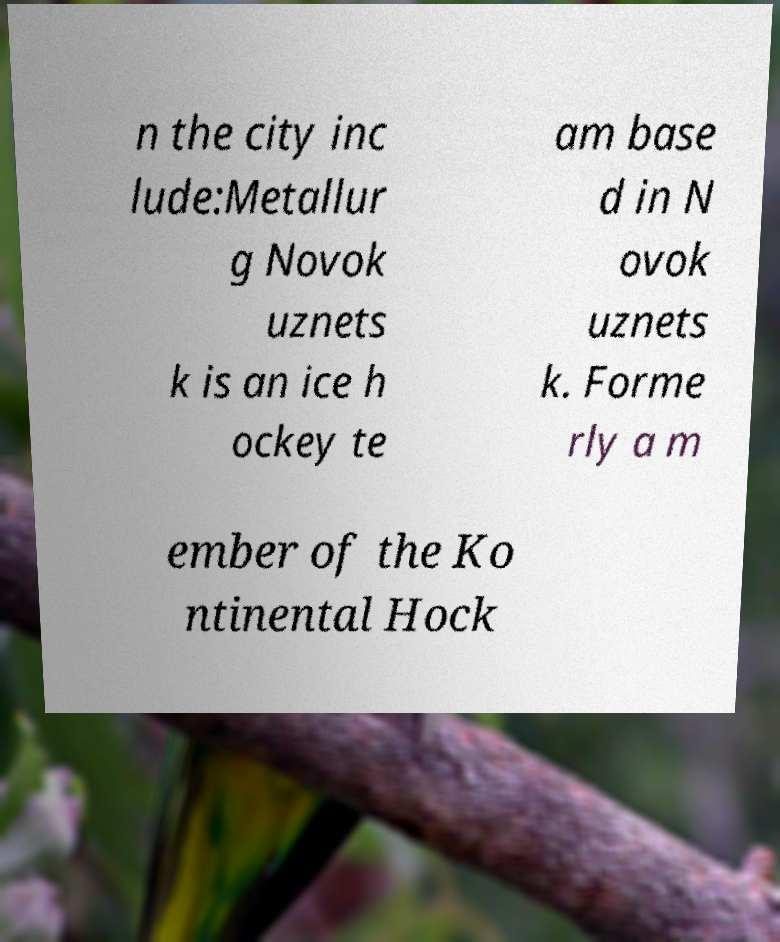What messages or text are displayed in this image? I need them in a readable, typed format. n the city inc lude:Metallur g Novok uznets k is an ice h ockey te am base d in N ovok uznets k. Forme rly a m ember of the Ko ntinental Hock 